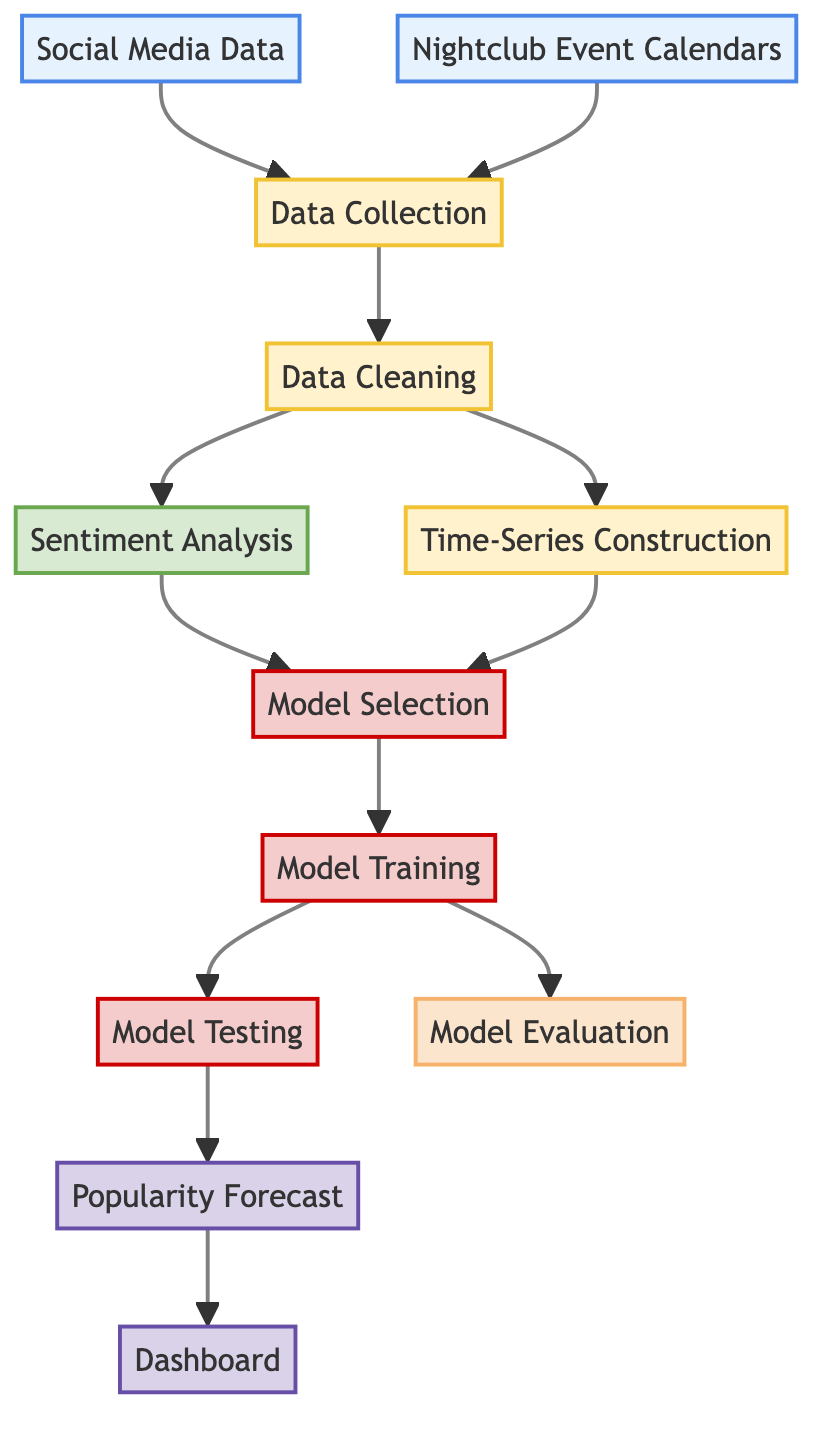What are the two sources of data in this diagram? The diagram shows two primary sources of data: "Social Media Data" and "Nightclub Event Calendars." Both sources feed into the "Data Collection" process.
Answer: Social Media Data, Nightclub Event Calendars What is the final output of this diagram? According to the diagram, the final outputs are "Popularity Forecast" and "Dashboard." These nodes represent the results generated after the modeling process.
Answer: Popularity Forecast, Dashboard How many processing steps are there in the diagram? The diagram includes several processing steps: "Data Collection," "Data Cleaning," "Sentiment Analysis," and "Time-Series Construction." Counting these gives a total of four processing steps.
Answer: 4 Which process comes after "Data Cleaning"? After the "Data Cleaning" step, the next processes in the flow are "Sentiment Analysis" and "Time-Series Construction," both of which occur simultaneously.
Answer: Sentiment Analysis, Time-Series Construction What is the relationship between "Model Training" and "Model Testing"? The diagram illustrates that "Model Testing" follows "Model Training," indicating that model testing occurs after the model has been trained.
Answer: Model Testing follows Model Training What do nodes 8 and 12 have in common? Both nodes represent stages in the model-building process. Node 8, "Model Training," leads to node 12, "Model Evaluation," which is specifically concerned with assessing the trained model.
Answer: Model Training, Model Evaluation How many nodes are classified as outputs? There are two distinct nodes classified as outputs: "Popularity Forecast" and "Dashboard." They represent the results desired from the entire machine learning process depicted in the diagram.
Answer: 2 What is the last node following the "Model Testing"? The node that immediately follows "Model Testing" is "Popularity Forecast," indicating that predictions about nightclub popularity are made after testing the model.
Answer: Popularity Forecast 